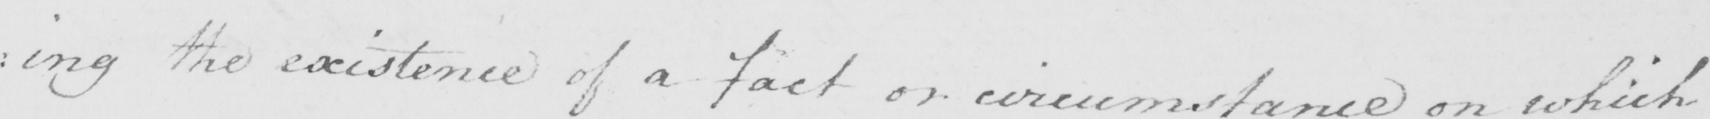What text is written in this handwritten line? the existence of a fact or circumstance on which 